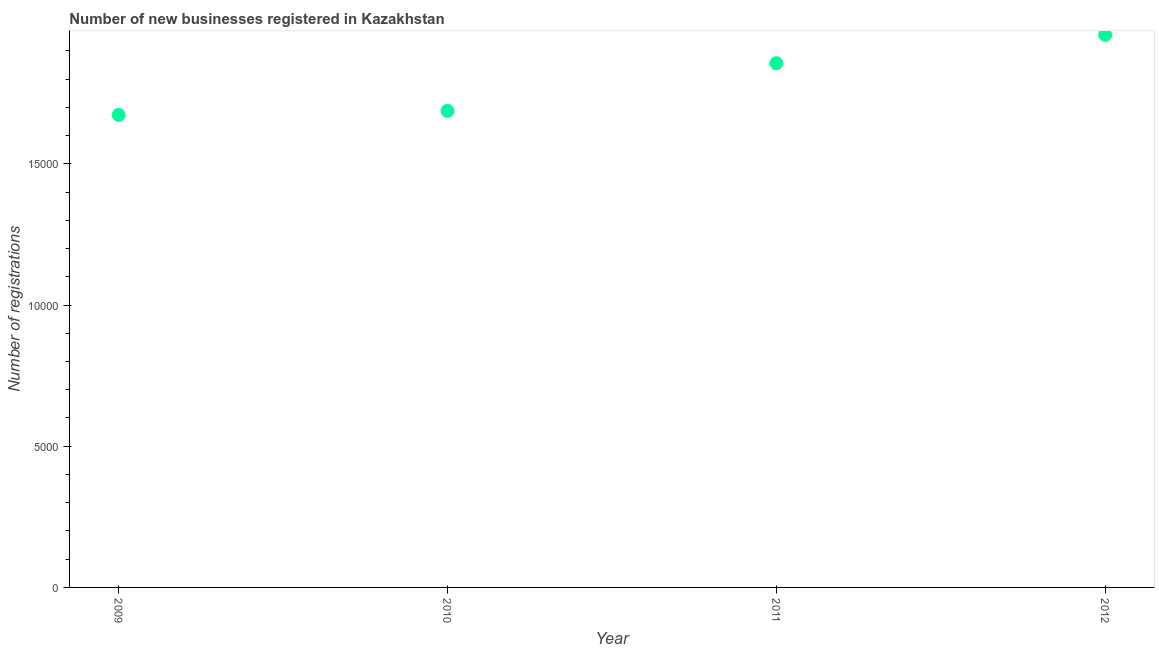What is the number of new business registrations in 2010?
Keep it short and to the point. 1.69e+04. Across all years, what is the maximum number of new business registrations?
Make the answer very short. 1.96e+04. Across all years, what is the minimum number of new business registrations?
Your answer should be very brief. 1.67e+04. In which year was the number of new business registrations maximum?
Your answer should be compact. 2012. In which year was the number of new business registrations minimum?
Give a very brief answer. 2009. What is the sum of the number of new business registrations?
Give a very brief answer. 7.17e+04. What is the difference between the number of new business registrations in 2010 and 2011?
Offer a terse response. -1688. What is the average number of new business registrations per year?
Make the answer very short. 1.79e+04. What is the median number of new business registrations?
Your answer should be compact. 1.77e+04. What is the ratio of the number of new business registrations in 2009 to that in 2012?
Provide a short and direct response. 0.86. Is the number of new business registrations in 2009 less than that in 2011?
Offer a terse response. Yes. What is the difference between the highest and the second highest number of new business registrations?
Offer a terse response. 1005. Is the sum of the number of new business registrations in 2009 and 2012 greater than the maximum number of new business registrations across all years?
Your answer should be very brief. Yes. What is the difference between the highest and the lowest number of new business registrations?
Your answer should be compact. 2834. Does the number of new business registrations monotonically increase over the years?
Give a very brief answer. Yes. How many dotlines are there?
Provide a succinct answer. 1. What is the difference between two consecutive major ticks on the Y-axis?
Provide a succinct answer. 5000. Does the graph contain any zero values?
Ensure brevity in your answer.  No. What is the title of the graph?
Provide a short and direct response. Number of new businesses registered in Kazakhstan. What is the label or title of the Y-axis?
Ensure brevity in your answer.  Number of registrations. What is the Number of registrations in 2009?
Your answer should be compact. 1.67e+04. What is the Number of registrations in 2010?
Offer a terse response. 1.69e+04. What is the Number of registrations in 2011?
Offer a terse response. 1.86e+04. What is the Number of registrations in 2012?
Provide a short and direct response. 1.96e+04. What is the difference between the Number of registrations in 2009 and 2010?
Make the answer very short. -141. What is the difference between the Number of registrations in 2009 and 2011?
Your answer should be very brief. -1829. What is the difference between the Number of registrations in 2009 and 2012?
Your answer should be compact. -2834. What is the difference between the Number of registrations in 2010 and 2011?
Ensure brevity in your answer.  -1688. What is the difference between the Number of registrations in 2010 and 2012?
Ensure brevity in your answer.  -2693. What is the difference between the Number of registrations in 2011 and 2012?
Give a very brief answer. -1005. What is the ratio of the Number of registrations in 2009 to that in 2010?
Keep it short and to the point. 0.99. What is the ratio of the Number of registrations in 2009 to that in 2011?
Provide a succinct answer. 0.9. What is the ratio of the Number of registrations in 2009 to that in 2012?
Ensure brevity in your answer.  0.85. What is the ratio of the Number of registrations in 2010 to that in 2011?
Offer a very short reply. 0.91. What is the ratio of the Number of registrations in 2010 to that in 2012?
Provide a short and direct response. 0.86. What is the ratio of the Number of registrations in 2011 to that in 2012?
Your answer should be compact. 0.95. 